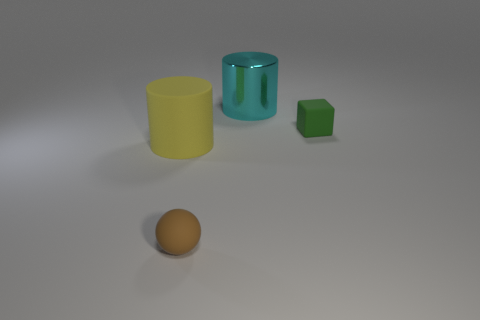The other matte object that is the same shape as the cyan object is what size?
Your answer should be very brief. Large. There is a metallic thing that is the same shape as the big yellow matte object; what color is it?
Keep it short and to the point. Cyan. How many brown rubber objects have the same shape as the yellow object?
Give a very brief answer. 0. The object that is to the right of the brown rubber thing and in front of the metal cylinder is made of what material?
Provide a short and direct response. Rubber. Is the material of the tiny green object the same as the sphere?
Offer a terse response. Yes. How many tiny green rubber cylinders are there?
Your response must be concise. 0. There is a small thing that is on the right side of the object that is in front of the cylinder in front of the small green rubber block; what color is it?
Make the answer very short. Green. Do the sphere and the cube have the same color?
Offer a terse response. No. How many objects are both in front of the big metal cylinder and on the left side of the tiny green matte block?
Provide a short and direct response. 2. How many rubber things are tiny brown things or yellow cylinders?
Your answer should be very brief. 2. 